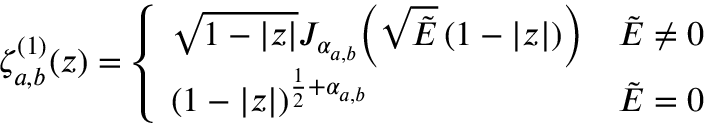<formula> <loc_0><loc_0><loc_500><loc_500>\zeta _ { a , b } ^ { ( 1 ) } ( z ) = \left \{ \begin{array} { l l } { \sqrt { 1 - | z | } J _ { \alpha _ { a , b } } \, \left ( \sqrt { \tilde { E } } \left ( 1 - | z | \right ) \right ) } & { \tilde { E } \neq 0 } \\ { { \left ( 1 - | z | \right ) } ^ { \frac { 1 } { 2 } + { \alpha _ { a , b } } } } & { \tilde { E } = 0 } \end{array}</formula> 